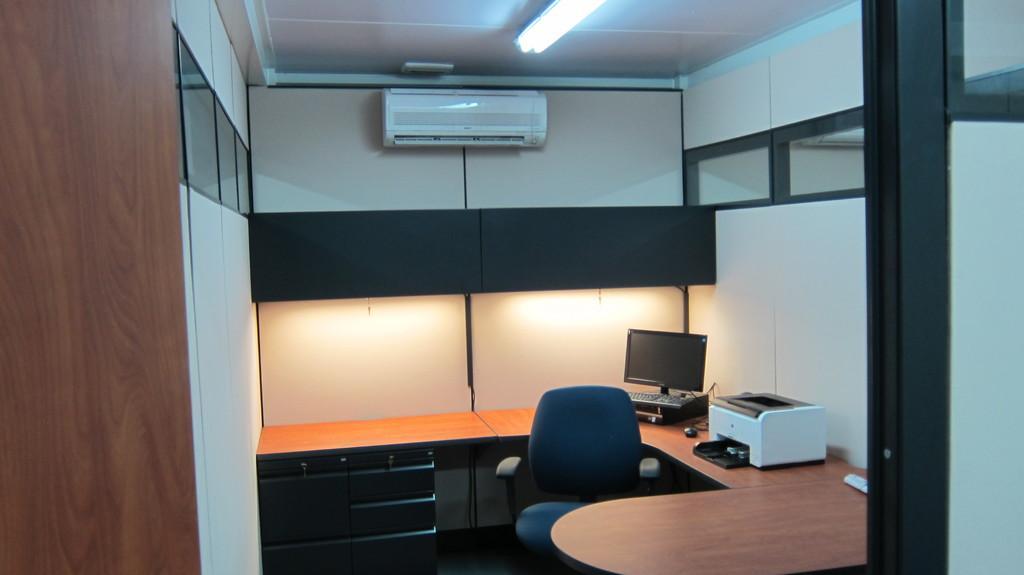Could you give a brief overview of what you see in this image? This image is clicked in a room. There is a light on the top. There is a, an AC on the top. There are tables in this room and a chair. On the table there is computer and printer. 